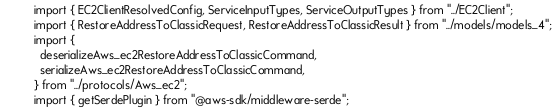<code> <loc_0><loc_0><loc_500><loc_500><_TypeScript_>import { EC2ClientResolvedConfig, ServiceInputTypes, ServiceOutputTypes } from "../EC2Client";
import { RestoreAddressToClassicRequest, RestoreAddressToClassicResult } from "../models/models_4";
import {
  deserializeAws_ec2RestoreAddressToClassicCommand,
  serializeAws_ec2RestoreAddressToClassicCommand,
} from "../protocols/Aws_ec2";
import { getSerdePlugin } from "@aws-sdk/middleware-serde";</code> 